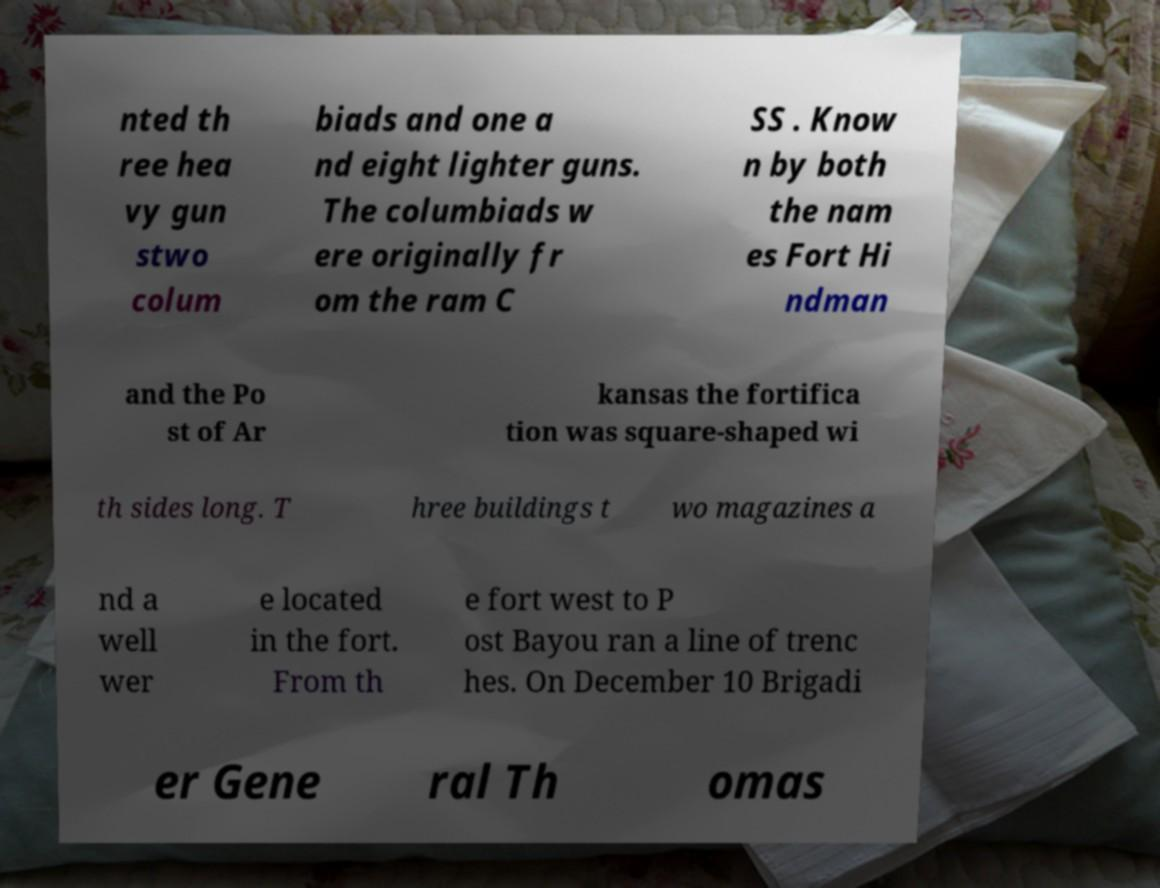Can you accurately transcribe the text from the provided image for me? nted th ree hea vy gun stwo colum biads and one a nd eight lighter guns. The columbiads w ere originally fr om the ram C SS . Know n by both the nam es Fort Hi ndman and the Po st of Ar kansas the fortifica tion was square-shaped wi th sides long. T hree buildings t wo magazines a nd a well wer e located in the fort. From th e fort west to P ost Bayou ran a line of trenc hes. On December 10 Brigadi er Gene ral Th omas 